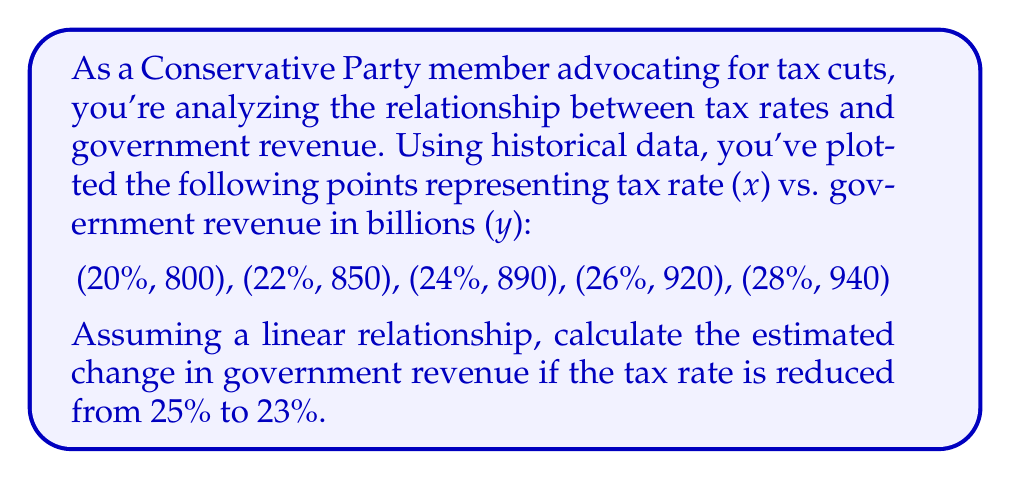Teach me how to tackle this problem. To solve this problem, we'll use linear regression to find the line of best fit, then use it to estimate the change in revenue.

1. Calculate the means of x and y:
   $\bar{x} = \frac{20 + 22 + 24 + 26 + 28}{5} = 24$
   $\bar{y} = \frac{800 + 850 + 890 + 920 + 940}{5} = 880$

2. Calculate the slope (m) using the formula:
   $$m = \frac{\sum(x_i - \bar{x})(y_i - \bar{y})}{\sum(x_i - \bar{x})^2}$$

   $\sum(x_i - \bar{x})(y_i - \bar{y}) = (-4)(-80) + (-2)(-30) + (0)(10) + (2)(40) + (4)(60) = 520$
   $\sum(x_i - \bar{x})^2 = (-4)^2 + (-2)^2 + 0^2 + 2^2 + 4^2 = 40$

   $m = \frac{520}{40} = 13$

3. Calculate the y-intercept (b) using $y = mx + b$:
   $880 = 13(24) + b$
   $b = 880 - 312 = 568$

4. The line of best fit is $y = 13x + 568$

5. Calculate the estimated revenue at 25% and 23%:
   At 25%: $y = 13(25) + 568 = 893$
   At 23%: $y = 13(23) + 568 = 867$

6. Calculate the difference:
   $893 - 867 = 26$

Therefore, the estimated change in government revenue when reducing the tax rate from 25% to 23% is a decrease of 26 billion.
Answer: -26 billion 